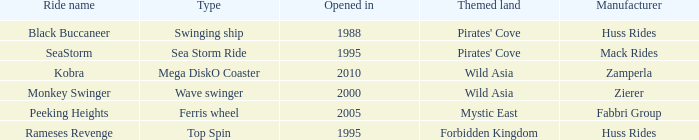What type ride is Wild Asia that opened in 2000? Wave swinger. 